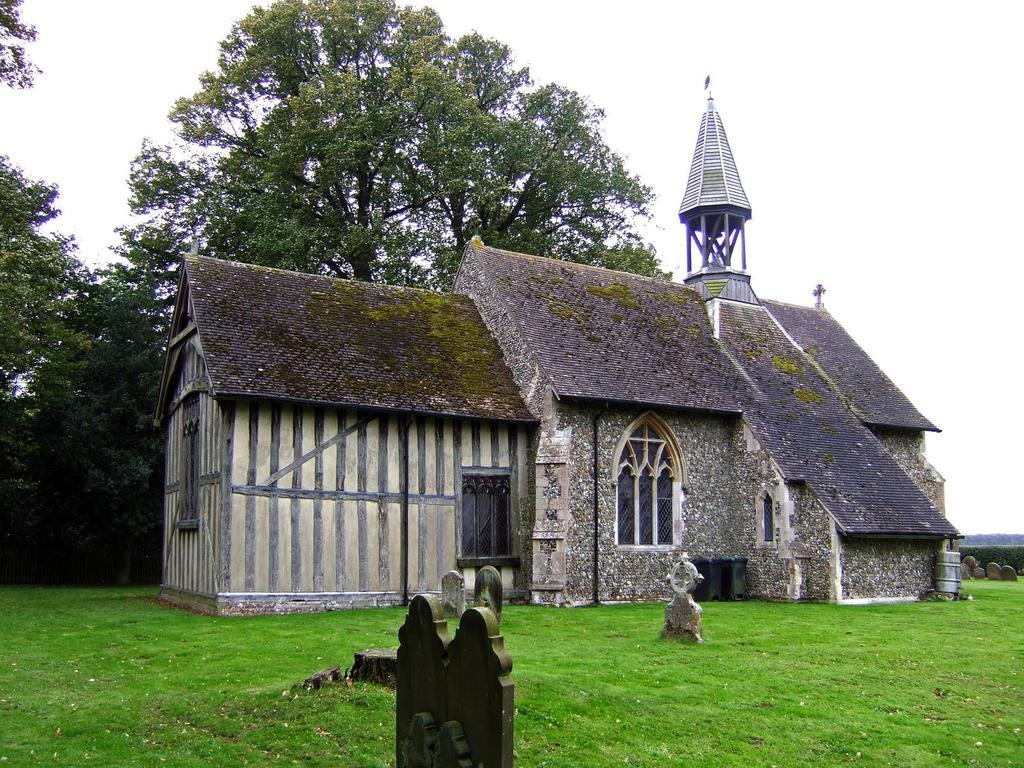What is in the foreground of the image? There is grass and a house in the foreground of the image. What can be seen in the background of the image? There are trees and the sky in the background of the image. What time of day was the image taken? The image was taken during the day. What type of cake is being served on the grass in the image? There is no cake present in the image; it features grass and a house in the foreground. What type of grain is visible in the background of the image? There is no grain visible in the image; it features trees and the sky in the background. 